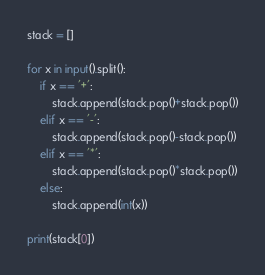Convert code to text. <code><loc_0><loc_0><loc_500><loc_500><_Python_>stack = []

for x in input().split():
    if x == '+':
        stack.append(stack.pop()+stack.pop())
    elif x == '-':
        stack.append(stack.pop()-stack.pop())
    elif x == '*':
        stack.append(stack.pop()*stack.pop())
    else:
        stack.append(int(x))

print(stack[0])
</code> 